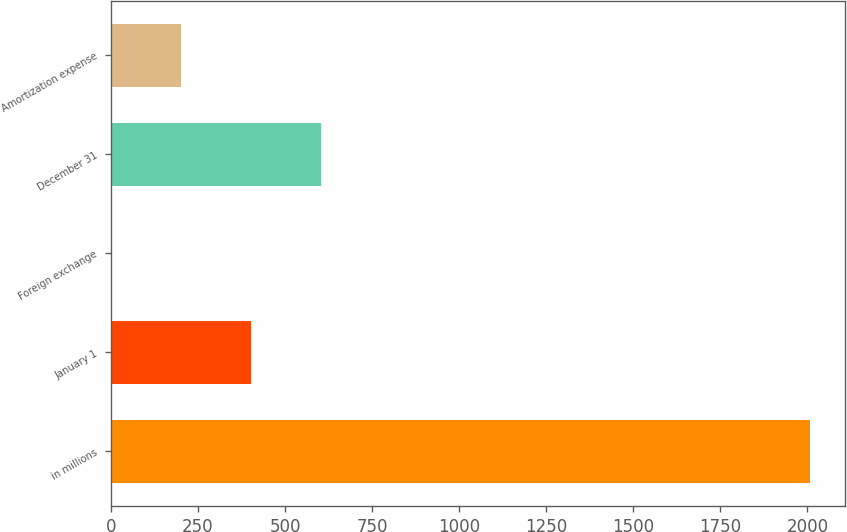<chart> <loc_0><loc_0><loc_500><loc_500><bar_chart><fcel>in millions<fcel>January 1<fcel>Foreign exchange<fcel>December 31<fcel>Amortization expense<nl><fcel>2009<fcel>401.96<fcel>0.2<fcel>602.84<fcel>201.08<nl></chart> 